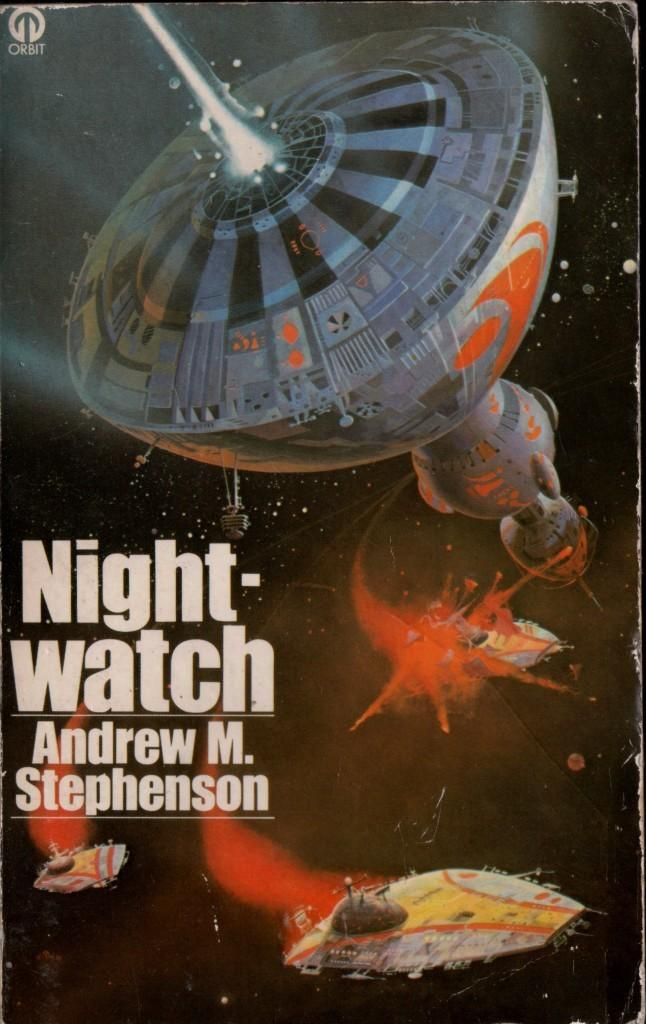Provide a one-sentence caption for the provided image. A gently used copy of Night-watch by Andrew M. Stephenson. 